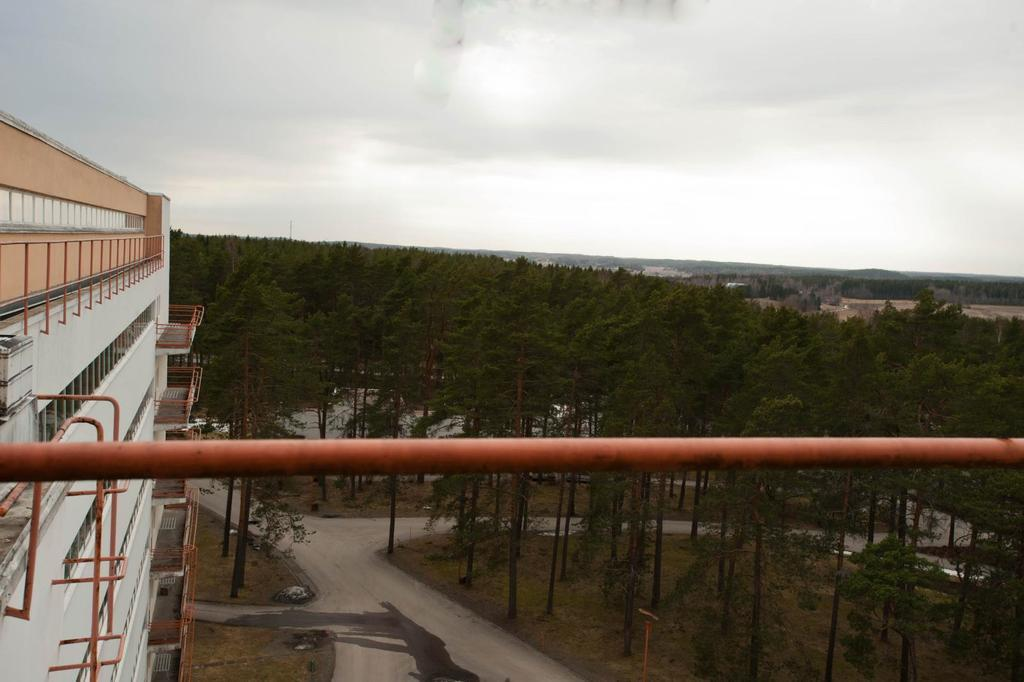What is the main object made of metal in the image? There is a metal rod in the image. Where can the metal rod be found in the image? The metal rod is part of a building with metal rods in the image. What type of vegetation is visible in front of the building? There are trees in front of the building. What type of pathway is present in the image? There is a road in the image. Who is the representative of the destruction caused by the metal rods in the image? There is no representative of destruction in the image, and the metal rods are not causing any destruction. 